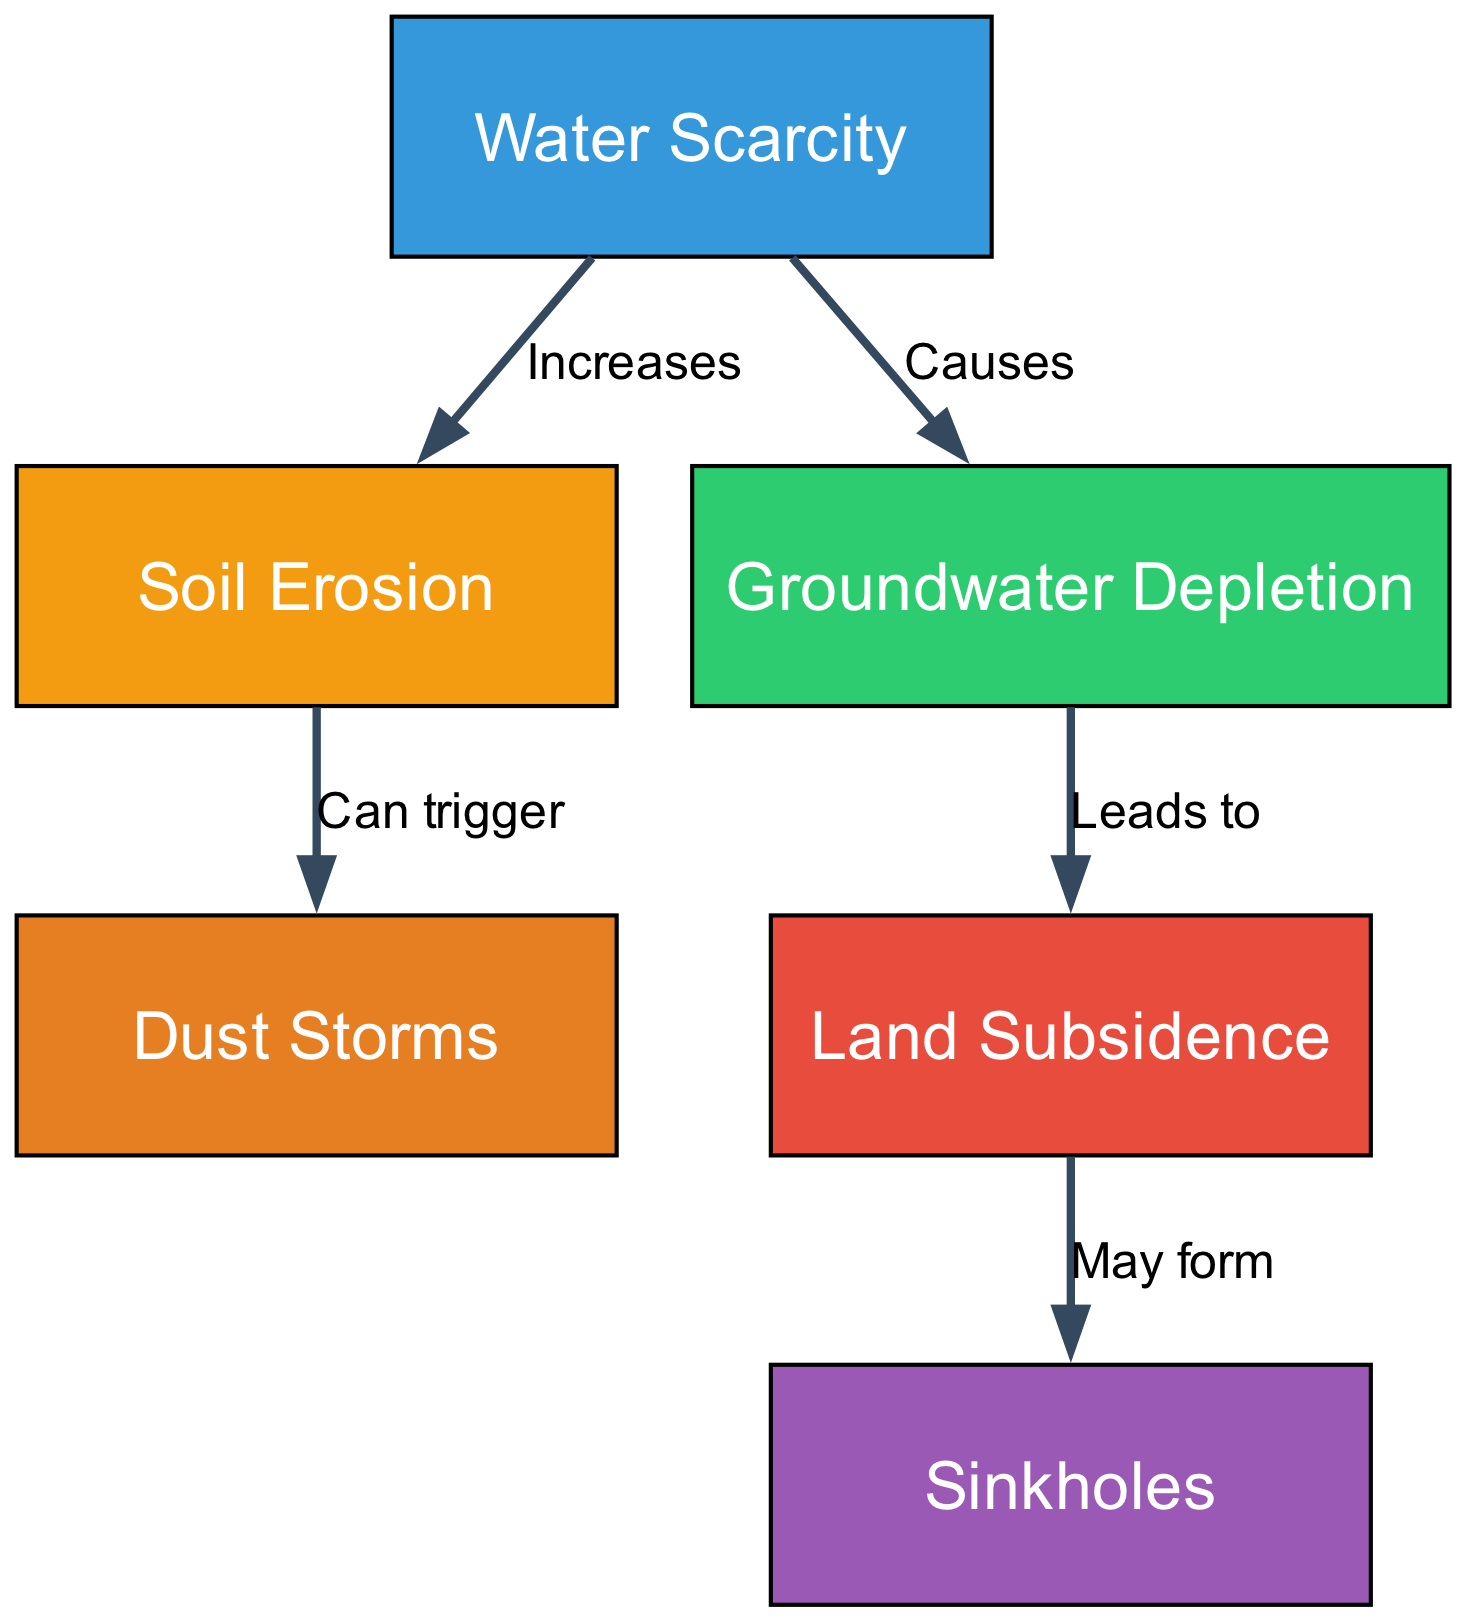What causes groundwater depletion? According to the diagram, groundwater depletion is directly caused by water scarcity, as indicated by the directed edge from "water scarcity" to "groundwater depletion" labeled "Causes."
Answer: Water scarcity What hazard may form from land subsidence? The diagram shows that land subsidence may lead to the formation of sinkholes, as evidenced by the arrow from "land subsidence" to "sinkholes" labeled "May form."
Answer: Sinkholes How many edges are in the diagram? By counting the directed connections (edges) that describe relationships between nodes in the diagram, there are a total of five edges.
Answer: 5 What does soil erosion increase? The diagram illustrates that soil erosion is increased by water scarcity, as stated by the connection from "water scarcity" to "soil erosion" labeled "Increases."
Answer: Soil erosion What can soil erosion trigger? The diagram indicates that soil erosion can trigger dust storms, represented by the edge from "soil erosion" to "dust storms" labeled "Can trigger."
Answer: Dust storms What leads to land subsidence? According to the diagram, groundwater depletion leads to land subsidence, as shown by the arrow from "groundwater depletion" to "land subsidence" labeled "Leads to."
Answer: Groundwater depletion Which node has the highest risk level based on the diagram's color? In the diagram, the node representing land subsidence is colored red (#e74c3c), which typically indicates a higher risk level. Hence, it has the highest risk level according to its color representation.
Answer: Land subsidence How many main geological hazards are indicated in the diagram? The diagram outlines three main geological hazards: land subsidence, soil erosion, and sinkholes, as separate nodes that are influenced by water scarcity.
Answer: 3 